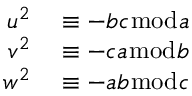<formula> <loc_0><loc_0><loc_500><loc_500>\begin{array} { r l } { u ^ { 2 } } & \equiv - b c { \bmod { a } } } \\ { v ^ { 2 } } & \equiv - c a { \bmod { b } } } \\ { w ^ { 2 } } & \equiv - a b { \bmod { c } } } \end{array}</formula> 